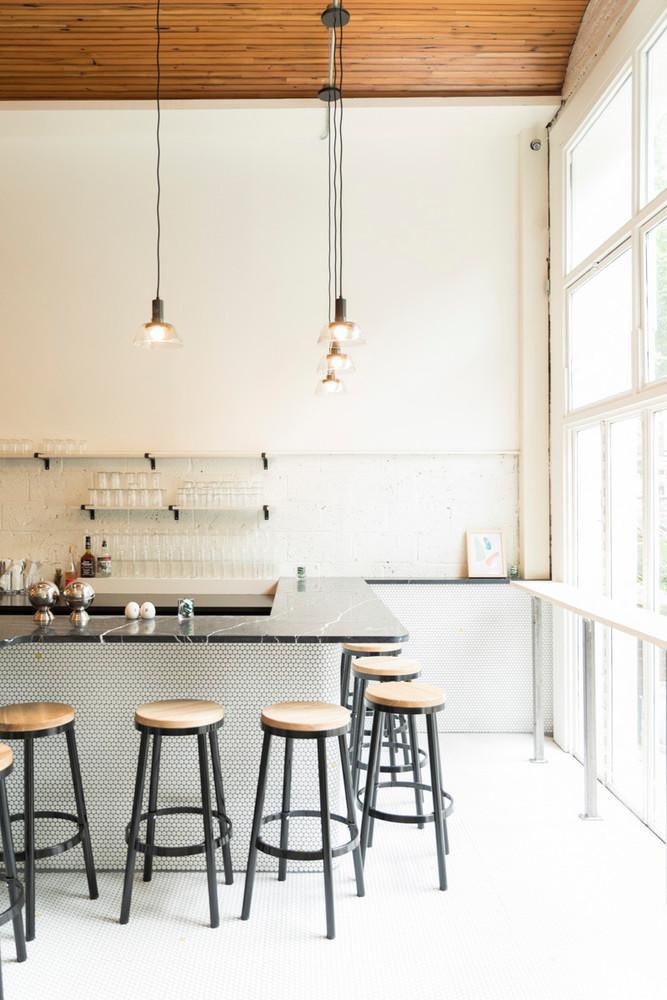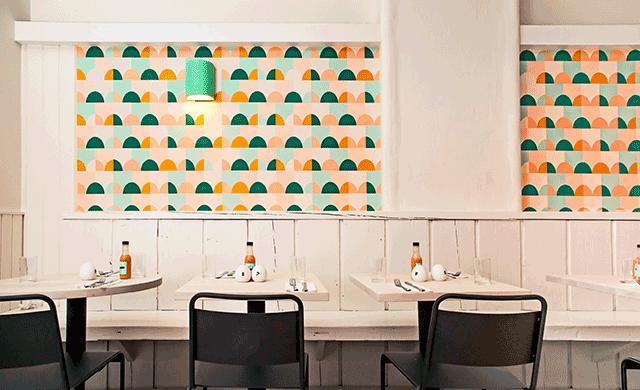The first image is the image on the left, the second image is the image on the right. Given the left and right images, does the statement "Each image shows a seating area with lights suspended over it, and one of the images features black chairs in front of small square tables flush with a low wall." hold true? Answer yes or no. Yes. The first image is the image on the left, the second image is the image on the right. Analyze the images presented: Is the assertion "There are chairs in both images." valid? Answer yes or no. Yes. 